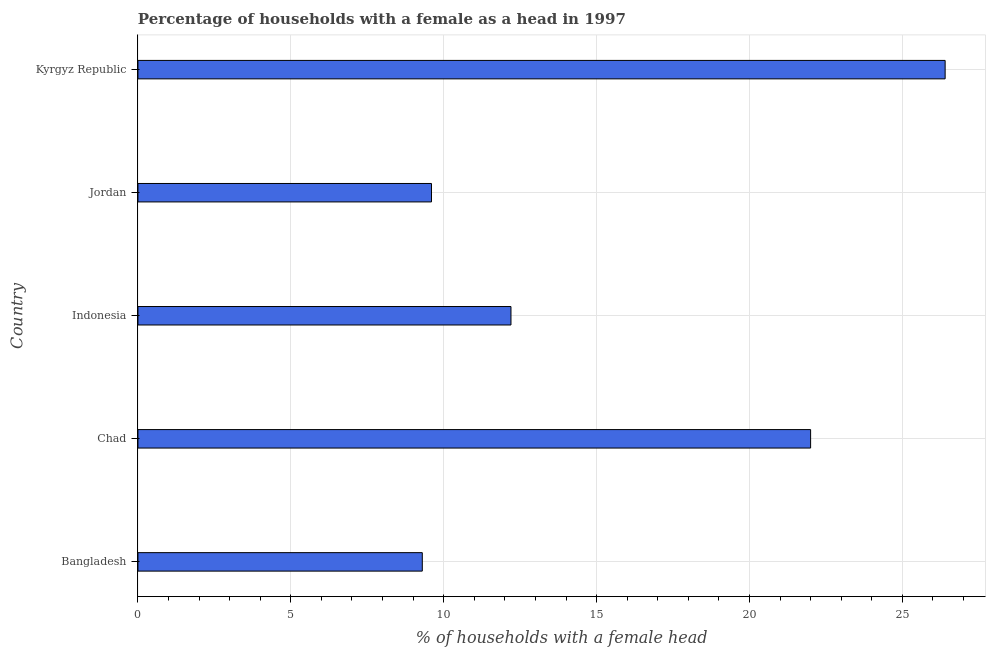Does the graph contain any zero values?
Make the answer very short. No. What is the title of the graph?
Keep it short and to the point. Percentage of households with a female as a head in 1997. What is the label or title of the X-axis?
Your answer should be compact. % of households with a female head. What is the number of female supervised households in Kyrgyz Republic?
Offer a very short reply. 26.4. Across all countries, what is the maximum number of female supervised households?
Provide a short and direct response. 26.4. Across all countries, what is the minimum number of female supervised households?
Give a very brief answer. 9.3. In which country was the number of female supervised households maximum?
Offer a terse response. Kyrgyz Republic. What is the sum of the number of female supervised households?
Your answer should be compact. 79.5. In how many countries, is the number of female supervised households greater than 9 %?
Give a very brief answer. 5. What is the ratio of the number of female supervised households in Bangladesh to that in Kyrgyz Republic?
Your response must be concise. 0.35. What is the difference between the highest and the second highest number of female supervised households?
Provide a succinct answer. 4.4. What is the difference between the highest and the lowest number of female supervised households?
Provide a succinct answer. 17.1. In how many countries, is the number of female supervised households greater than the average number of female supervised households taken over all countries?
Make the answer very short. 2. How many bars are there?
Keep it short and to the point. 5. What is the difference between two consecutive major ticks on the X-axis?
Your response must be concise. 5. Are the values on the major ticks of X-axis written in scientific E-notation?
Provide a short and direct response. No. What is the % of households with a female head in Bangladesh?
Ensure brevity in your answer.  9.3. What is the % of households with a female head of Indonesia?
Your response must be concise. 12.2. What is the % of households with a female head of Jordan?
Provide a short and direct response. 9.6. What is the % of households with a female head of Kyrgyz Republic?
Your answer should be very brief. 26.4. What is the difference between the % of households with a female head in Bangladesh and Jordan?
Give a very brief answer. -0.3. What is the difference between the % of households with a female head in Bangladesh and Kyrgyz Republic?
Make the answer very short. -17.1. What is the difference between the % of households with a female head in Chad and Jordan?
Offer a very short reply. 12.4. What is the difference between the % of households with a female head in Indonesia and Kyrgyz Republic?
Give a very brief answer. -14.2. What is the difference between the % of households with a female head in Jordan and Kyrgyz Republic?
Ensure brevity in your answer.  -16.8. What is the ratio of the % of households with a female head in Bangladesh to that in Chad?
Ensure brevity in your answer.  0.42. What is the ratio of the % of households with a female head in Bangladesh to that in Indonesia?
Your answer should be very brief. 0.76. What is the ratio of the % of households with a female head in Bangladesh to that in Jordan?
Keep it short and to the point. 0.97. What is the ratio of the % of households with a female head in Bangladesh to that in Kyrgyz Republic?
Your answer should be compact. 0.35. What is the ratio of the % of households with a female head in Chad to that in Indonesia?
Offer a very short reply. 1.8. What is the ratio of the % of households with a female head in Chad to that in Jordan?
Offer a terse response. 2.29. What is the ratio of the % of households with a female head in Chad to that in Kyrgyz Republic?
Your answer should be very brief. 0.83. What is the ratio of the % of households with a female head in Indonesia to that in Jordan?
Your response must be concise. 1.27. What is the ratio of the % of households with a female head in Indonesia to that in Kyrgyz Republic?
Make the answer very short. 0.46. What is the ratio of the % of households with a female head in Jordan to that in Kyrgyz Republic?
Your answer should be compact. 0.36. 